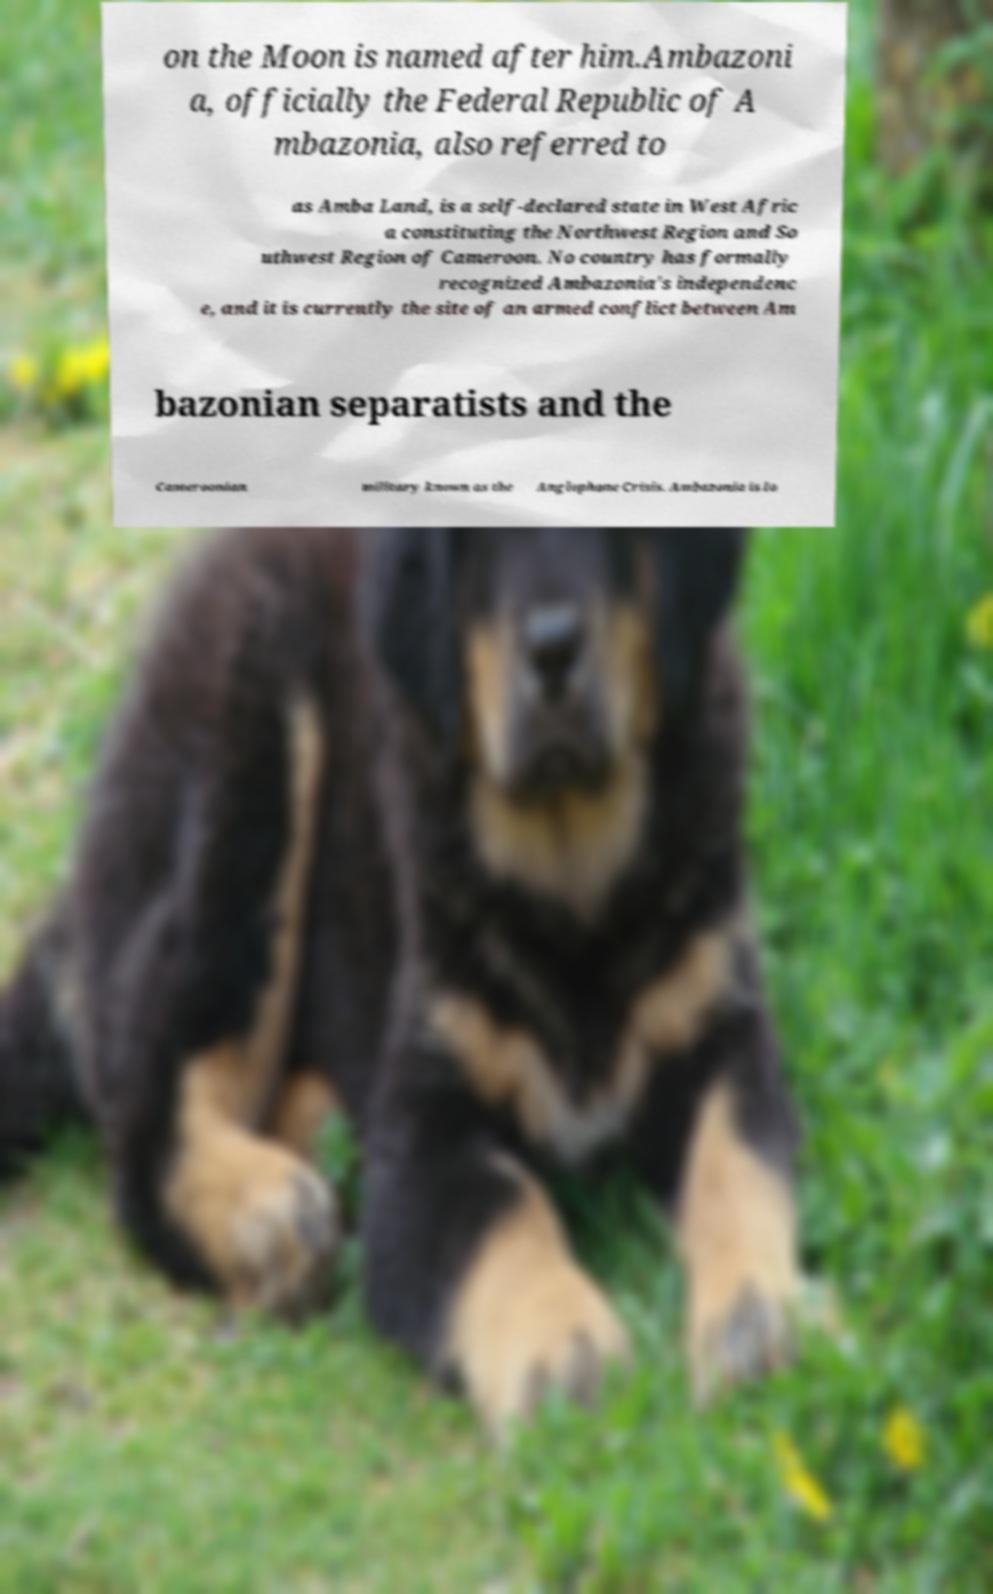Please read and relay the text visible in this image. What does it say? on the Moon is named after him.Ambazoni a, officially the Federal Republic of A mbazonia, also referred to as Amba Land, is a self-declared state in West Afric a constituting the Northwest Region and So uthwest Region of Cameroon. No country has formally recognized Ambazonia's independenc e, and it is currently the site of an armed conflict between Am bazonian separatists and the Cameroonian military known as the Anglophone Crisis. Ambazonia is lo 